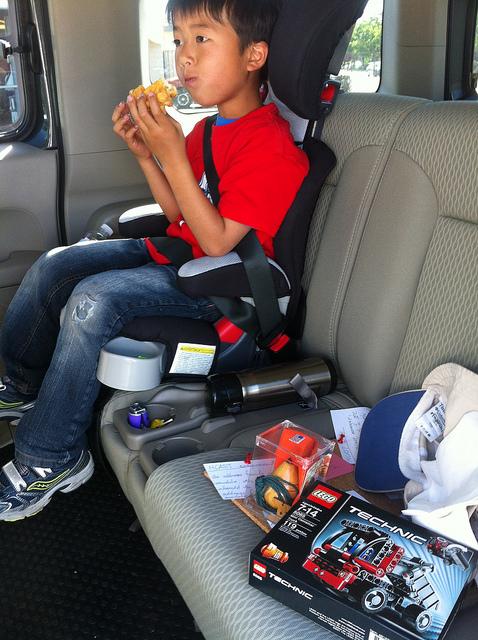What toy is in the box?
Give a very brief answer. Legos. What is the purple item in the cup holder?
Short answer required. Toy. What is the boy eating?
Answer briefly. Yes. What is on display in the foreground?
Be succinct. Legos. Are those leather seats?
Keep it brief. No. 